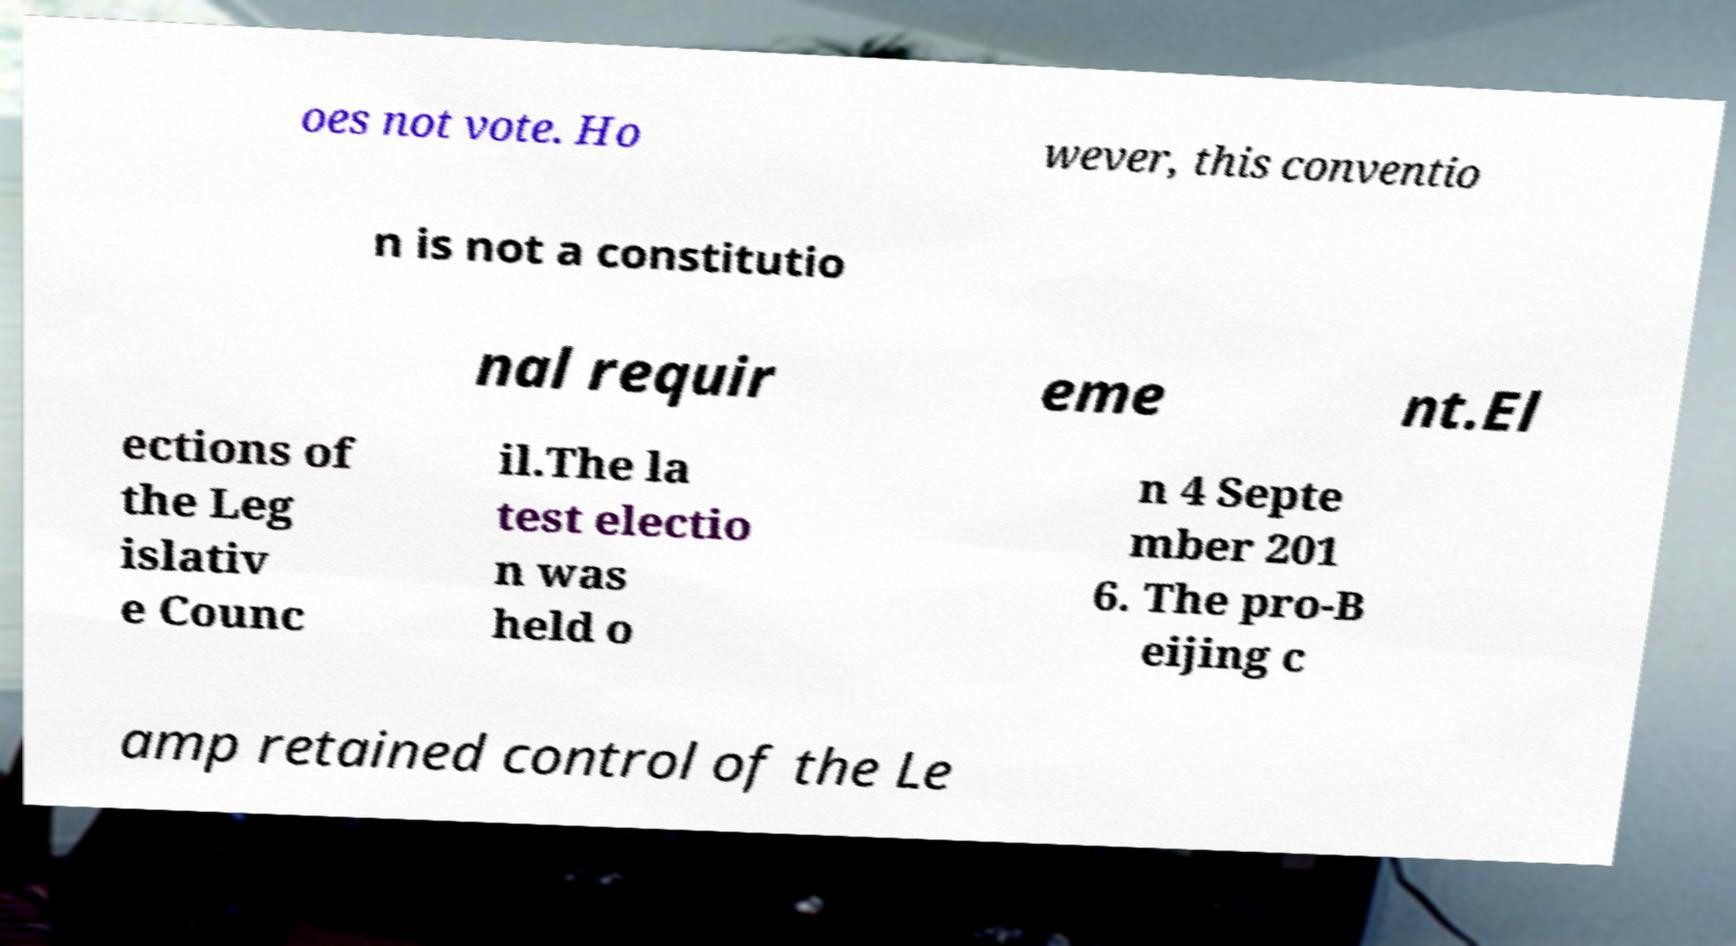Could you assist in decoding the text presented in this image and type it out clearly? oes not vote. Ho wever, this conventio n is not a constitutio nal requir eme nt.El ections of the Leg islativ e Counc il.The la test electio n was held o n 4 Septe mber 201 6. The pro-B eijing c amp retained control of the Le 